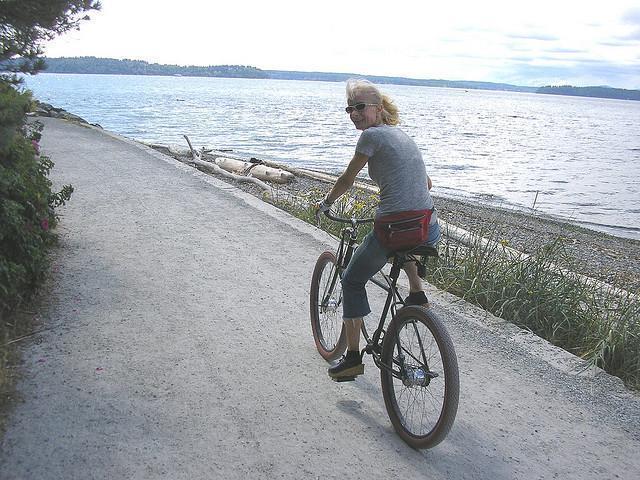Which wrong furnishing has the woman put on?
Select the accurate answer and provide explanation: 'Answer: answer
Rationale: rationale.'
Options: Pants, shoes, shirt, purse. Answer: shoes.
Rationale: The woman is wearing block heels to cycle. 